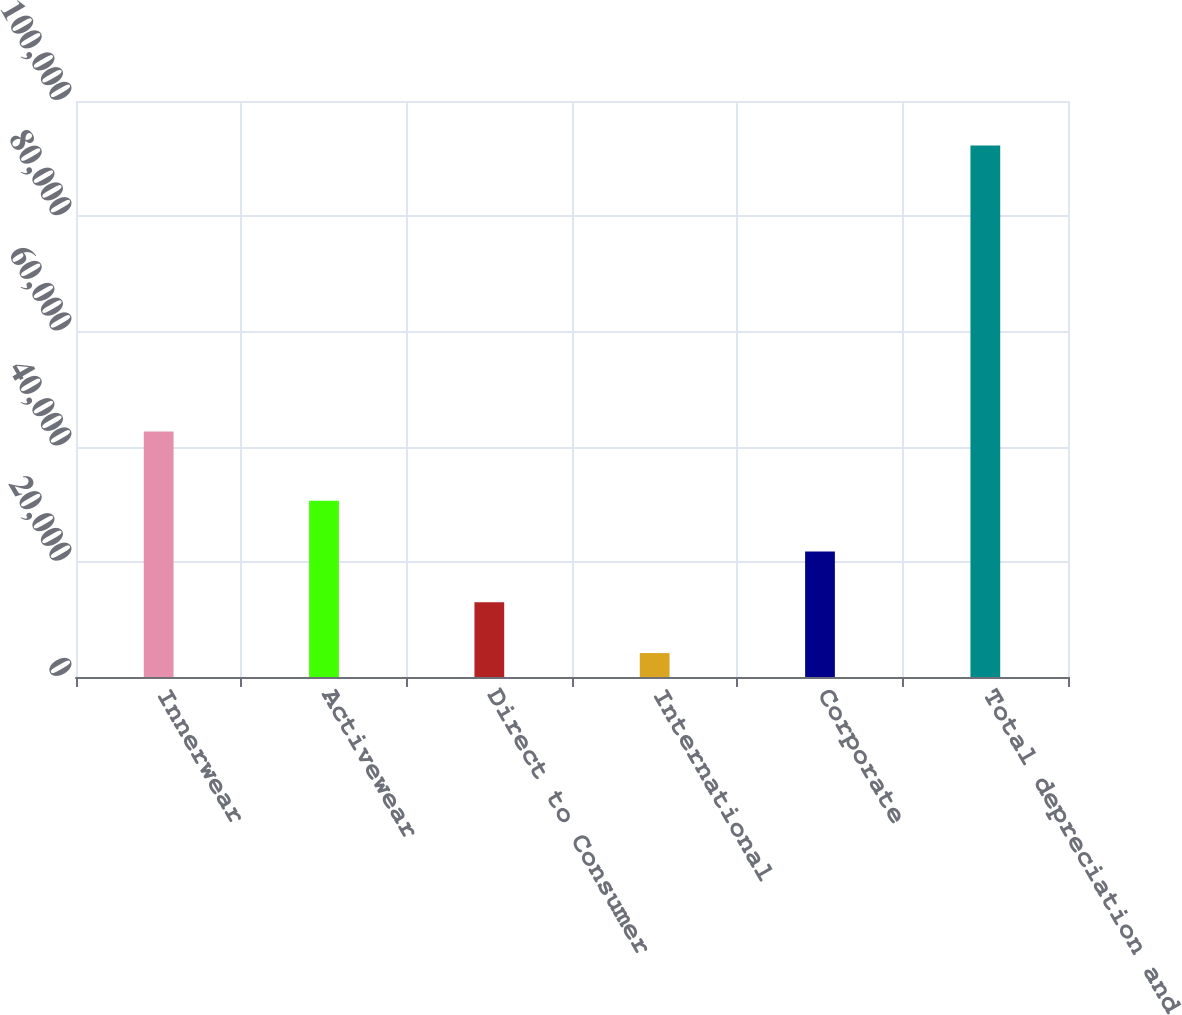<chart> <loc_0><loc_0><loc_500><loc_500><bar_chart><fcel>Innerwear<fcel>Activewear<fcel>Direct to Consumer<fcel>International<fcel>Corporate<fcel>Total depreciation and<nl><fcel>42617<fcel>30583.7<fcel>12963.9<fcel>4154<fcel>21773.8<fcel>92253<nl></chart> 